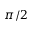Convert formula to latex. <formula><loc_0><loc_0><loc_500><loc_500>\pi / 2</formula> 